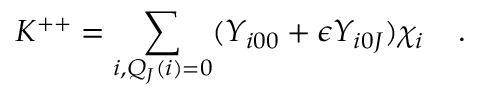Convert formula to latex. <formula><loc_0><loc_0><loc_500><loc_500>K ^ { + + } = \sum _ { i , Q _ { J } ( i ) = 0 } ( { Y } _ { i 0 0 } + \epsilon { Y } _ { i 0 J } ) { \chi } _ { i } \, .</formula> 